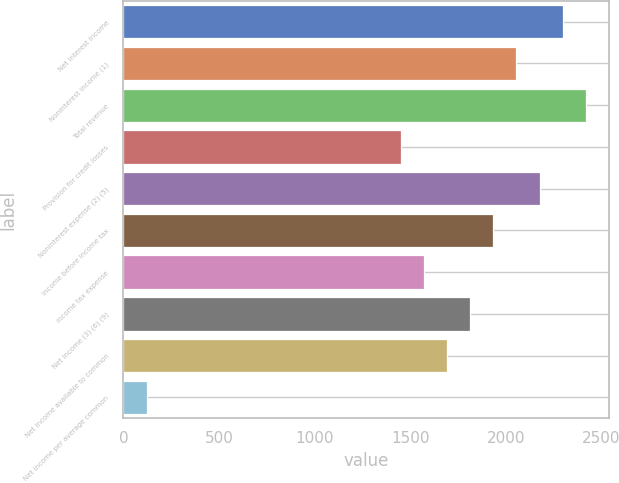<chart> <loc_0><loc_0><loc_500><loc_500><bar_chart><fcel>Net interest income<fcel>Noninterest income (1)<fcel>Total revenue<fcel>Provision for credit losses<fcel>Noninterest expense (2) (5)<fcel>Income before income tax<fcel>Income tax expense<fcel>Net income (3) (6) (9)<fcel>Net income available to common<fcel>Net income per average common<nl><fcel>2297.01<fcel>2055.23<fcel>2417.9<fcel>1450.78<fcel>2176.12<fcel>1934.34<fcel>1571.67<fcel>1813.45<fcel>1692.56<fcel>120.99<nl></chart> 